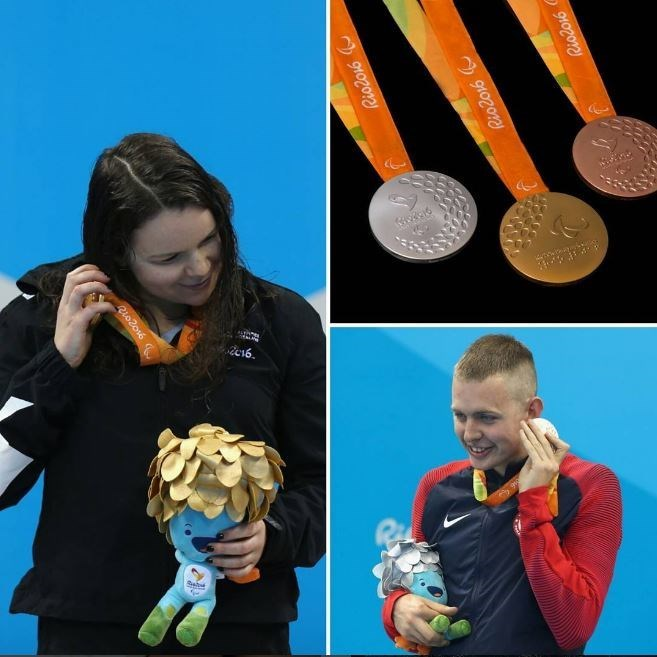Can the details of the medals provide insight into the ranking of the athletes in their respective events? Absolutely, the details of the medals can provide significant insight into the ranking of the athletes in their respective events. In the image, both athletes are holding silver medals. The color and design, featuring the Rio 2016 logo and an embossed pattern, distinctly indicate that these are silver medals. Silver medals are universally awarded to athletes who secure second place in their competitions. Consequently, it can be inferred that both athletes achieved second place in their respective sporting events during the Rio 2016 Olympic Games. 